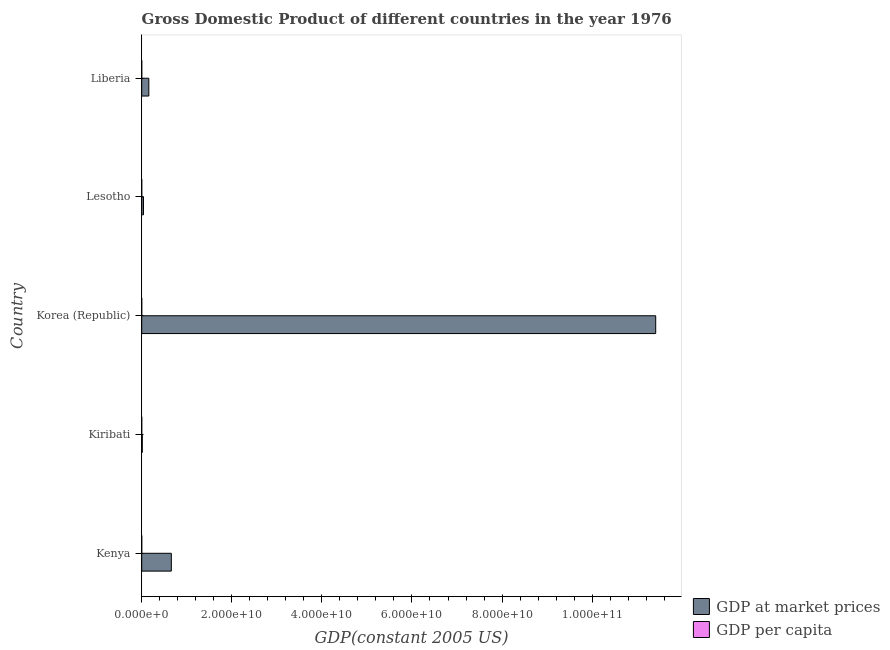Are the number of bars on each tick of the Y-axis equal?
Provide a succinct answer. Yes. How many bars are there on the 2nd tick from the top?
Give a very brief answer. 2. How many bars are there on the 2nd tick from the bottom?
Provide a succinct answer. 2. What is the label of the 4th group of bars from the top?
Your answer should be very brief. Kiribati. What is the gdp per capita in Lesotho?
Ensure brevity in your answer.  330.88. Across all countries, what is the maximum gdp at market prices?
Keep it short and to the point. 1.14e+11. Across all countries, what is the minimum gdp at market prices?
Keep it short and to the point. 1.24e+08. In which country was the gdp at market prices maximum?
Ensure brevity in your answer.  Korea (Republic). In which country was the gdp at market prices minimum?
Your answer should be very brief. Kiribati. What is the total gdp per capita in the graph?
Offer a very short reply. 7140.95. What is the difference between the gdp at market prices in Kenya and that in Lesotho?
Provide a short and direct response. 6.18e+09. What is the difference between the gdp per capita in Korea (Republic) and the gdp at market prices in Kiribati?
Provide a succinct answer. -1.24e+08. What is the average gdp at market prices per country?
Provide a succinct answer. 2.46e+1. What is the difference between the gdp at market prices and gdp per capita in Liberia?
Provide a short and direct response. 1.58e+09. In how many countries, is the gdp at market prices greater than 48000000000 US$?
Your answer should be very brief. 1. What is the ratio of the gdp at market prices in Kiribati to that in Lesotho?
Offer a terse response. 0.32. Is the difference between the gdp per capita in Kenya and Lesotho greater than the difference between the gdp at market prices in Kenya and Lesotho?
Provide a succinct answer. No. What is the difference between the highest and the second highest gdp at market prices?
Your response must be concise. 1.08e+11. What is the difference between the highest and the lowest gdp at market prices?
Your response must be concise. 1.14e+11. In how many countries, is the gdp at market prices greater than the average gdp at market prices taken over all countries?
Your response must be concise. 1. What does the 1st bar from the top in Korea (Republic) represents?
Your response must be concise. GDP per capita. What does the 2nd bar from the bottom in Lesotho represents?
Your answer should be very brief. GDP per capita. How many bars are there?
Give a very brief answer. 10. Are all the bars in the graph horizontal?
Provide a short and direct response. Yes. How many countries are there in the graph?
Your answer should be very brief. 5. Are the values on the major ticks of X-axis written in scientific E-notation?
Offer a very short reply. Yes. Does the graph contain any zero values?
Your answer should be compact. No. How many legend labels are there?
Give a very brief answer. 2. What is the title of the graph?
Your answer should be compact. Gross Domestic Product of different countries in the year 1976. What is the label or title of the X-axis?
Offer a terse response. GDP(constant 2005 US). What is the GDP(constant 2005 US) in GDP at market prices in Kenya?
Offer a very short reply. 6.57e+09. What is the GDP(constant 2005 US) in GDP per capita in Kenya?
Offer a terse response. 469.63. What is the GDP(constant 2005 US) in GDP at market prices in Kiribati?
Make the answer very short. 1.24e+08. What is the GDP(constant 2005 US) in GDP per capita in Kiribati?
Make the answer very short. 2216.2. What is the GDP(constant 2005 US) in GDP at market prices in Korea (Republic)?
Your response must be concise. 1.14e+11. What is the GDP(constant 2005 US) in GDP per capita in Korea (Republic)?
Your answer should be very brief. 3183.27. What is the GDP(constant 2005 US) of GDP at market prices in Lesotho?
Provide a succinct answer. 3.90e+08. What is the GDP(constant 2005 US) in GDP per capita in Lesotho?
Make the answer very short. 330.88. What is the GDP(constant 2005 US) in GDP at market prices in Liberia?
Offer a very short reply. 1.58e+09. What is the GDP(constant 2005 US) in GDP per capita in Liberia?
Give a very brief answer. 940.97. Across all countries, what is the maximum GDP(constant 2005 US) in GDP at market prices?
Give a very brief answer. 1.14e+11. Across all countries, what is the maximum GDP(constant 2005 US) of GDP per capita?
Your response must be concise. 3183.27. Across all countries, what is the minimum GDP(constant 2005 US) in GDP at market prices?
Provide a short and direct response. 1.24e+08. Across all countries, what is the minimum GDP(constant 2005 US) of GDP per capita?
Keep it short and to the point. 330.88. What is the total GDP(constant 2005 US) in GDP at market prices in the graph?
Your response must be concise. 1.23e+11. What is the total GDP(constant 2005 US) of GDP per capita in the graph?
Your answer should be compact. 7140.95. What is the difference between the GDP(constant 2005 US) of GDP at market prices in Kenya and that in Kiribati?
Your response must be concise. 6.45e+09. What is the difference between the GDP(constant 2005 US) of GDP per capita in Kenya and that in Kiribati?
Make the answer very short. -1746.57. What is the difference between the GDP(constant 2005 US) in GDP at market prices in Kenya and that in Korea (Republic)?
Offer a terse response. -1.08e+11. What is the difference between the GDP(constant 2005 US) of GDP per capita in Kenya and that in Korea (Republic)?
Your response must be concise. -2713.64. What is the difference between the GDP(constant 2005 US) of GDP at market prices in Kenya and that in Lesotho?
Give a very brief answer. 6.18e+09. What is the difference between the GDP(constant 2005 US) in GDP per capita in Kenya and that in Lesotho?
Your answer should be compact. 138.75. What is the difference between the GDP(constant 2005 US) of GDP at market prices in Kenya and that in Liberia?
Ensure brevity in your answer.  5.00e+09. What is the difference between the GDP(constant 2005 US) of GDP per capita in Kenya and that in Liberia?
Make the answer very short. -471.34. What is the difference between the GDP(constant 2005 US) of GDP at market prices in Kiribati and that in Korea (Republic)?
Give a very brief answer. -1.14e+11. What is the difference between the GDP(constant 2005 US) in GDP per capita in Kiribati and that in Korea (Republic)?
Ensure brevity in your answer.  -967.07. What is the difference between the GDP(constant 2005 US) of GDP at market prices in Kiribati and that in Lesotho?
Make the answer very short. -2.66e+08. What is the difference between the GDP(constant 2005 US) of GDP per capita in Kiribati and that in Lesotho?
Keep it short and to the point. 1885.33. What is the difference between the GDP(constant 2005 US) in GDP at market prices in Kiribati and that in Liberia?
Keep it short and to the point. -1.45e+09. What is the difference between the GDP(constant 2005 US) in GDP per capita in Kiribati and that in Liberia?
Your answer should be very brief. 1275.23. What is the difference between the GDP(constant 2005 US) of GDP at market prices in Korea (Republic) and that in Lesotho?
Your answer should be very brief. 1.14e+11. What is the difference between the GDP(constant 2005 US) of GDP per capita in Korea (Republic) and that in Lesotho?
Give a very brief answer. 2852.39. What is the difference between the GDP(constant 2005 US) in GDP at market prices in Korea (Republic) and that in Liberia?
Your answer should be compact. 1.13e+11. What is the difference between the GDP(constant 2005 US) of GDP per capita in Korea (Republic) and that in Liberia?
Your response must be concise. 2242.3. What is the difference between the GDP(constant 2005 US) in GDP at market prices in Lesotho and that in Liberia?
Your answer should be very brief. -1.19e+09. What is the difference between the GDP(constant 2005 US) in GDP per capita in Lesotho and that in Liberia?
Your response must be concise. -610.09. What is the difference between the GDP(constant 2005 US) in GDP at market prices in Kenya and the GDP(constant 2005 US) in GDP per capita in Kiribati?
Offer a very short reply. 6.57e+09. What is the difference between the GDP(constant 2005 US) of GDP at market prices in Kenya and the GDP(constant 2005 US) of GDP per capita in Korea (Republic)?
Provide a short and direct response. 6.57e+09. What is the difference between the GDP(constant 2005 US) in GDP at market prices in Kenya and the GDP(constant 2005 US) in GDP per capita in Lesotho?
Give a very brief answer. 6.57e+09. What is the difference between the GDP(constant 2005 US) of GDP at market prices in Kenya and the GDP(constant 2005 US) of GDP per capita in Liberia?
Give a very brief answer. 6.57e+09. What is the difference between the GDP(constant 2005 US) in GDP at market prices in Kiribati and the GDP(constant 2005 US) in GDP per capita in Korea (Republic)?
Offer a terse response. 1.24e+08. What is the difference between the GDP(constant 2005 US) in GDP at market prices in Kiribati and the GDP(constant 2005 US) in GDP per capita in Lesotho?
Make the answer very short. 1.24e+08. What is the difference between the GDP(constant 2005 US) in GDP at market prices in Kiribati and the GDP(constant 2005 US) in GDP per capita in Liberia?
Offer a terse response. 1.24e+08. What is the difference between the GDP(constant 2005 US) in GDP at market prices in Korea (Republic) and the GDP(constant 2005 US) in GDP per capita in Lesotho?
Your answer should be very brief. 1.14e+11. What is the difference between the GDP(constant 2005 US) of GDP at market prices in Korea (Republic) and the GDP(constant 2005 US) of GDP per capita in Liberia?
Offer a terse response. 1.14e+11. What is the difference between the GDP(constant 2005 US) in GDP at market prices in Lesotho and the GDP(constant 2005 US) in GDP per capita in Liberia?
Provide a short and direct response. 3.90e+08. What is the average GDP(constant 2005 US) in GDP at market prices per country?
Your response must be concise. 2.46e+1. What is the average GDP(constant 2005 US) of GDP per capita per country?
Provide a short and direct response. 1428.19. What is the difference between the GDP(constant 2005 US) of GDP at market prices and GDP(constant 2005 US) of GDP per capita in Kenya?
Your answer should be compact. 6.57e+09. What is the difference between the GDP(constant 2005 US) of GDP at market prices and GDP(constant 2005 US) of GDP per capita in Kiribati?
Ensure brevity in your answer.  1.24e+08. What is the difference between the GDP(constant 2005 US) in GDP at market prices and GDP(constant 2005 US) in GDP per capita in Korea (Republic)?
Ensure brevity in your answer.  1.14e+11. What is the difference between the GDP(constant 2005 US) of GDP at market prices and GDP(constant 2005 US) of GDP per capita in Lesotho?
Offer a very short reply. 3.90e+08. What is the difference between the GDP(constant 2005 US) in GDP at market prices and GDP(constant 2005 US) in GDP per capita in Liberia?
Provide a succinct answer. 1.58e+09. What is the ratio of the GDP(constant 2005 US) of GDP at market prices in Kenya to that in Kiribati?
Keep it short and to the point. 52.98. What is the ratio of the GDP(constant 2005 US) in GDP per capita in Kenya to that in Kiribati?
Your answer should be very brief. 0.21. What is the ratio of the GDP(constant 2005 US) of GDP at market prices in Kenya to that in Korea (Republic)?
Ensure brevity in your answer.  0.06. What is the ratio of the GDP(constant 2005 US) in GDP per capita in Kenya to that in Korea (Republic)?
Provide a succinct answer. 0.15. What is the ratio of the GDP(constant 2005 US) in GDP at market prices in Kenya to that in Lesotho?
Your answer should be compact. 16.86. What is the ratio of the GDP(constant 2005 US) of GDP per capita in Kenya to that in Lesotho?
Provide a short and direct response. 1.42. What is the ratio of the GDP(constant 2005 US) of GDP at market prices in Kenya to that in Liberia?
Your answer should be very brief. 4.17. What is the ratio of the GDP(constant 2005 US) in GDP per capita in Kenya to that in Liberia?
Provide a short and direct response. 0.5. What is the ratio of the GDP(constant 2005 US) in GDP at market prices in Kiribati to that in Korea (Republic)?
Keep it short and to the point. 0. What is the ratio of the GDP(constant 2005 US) in GDP per capita in Kiribati to that in Korea (Republic)?
Your response must be concise. 0.7. What is the ratio of the GDP(constant 2005 US) in GDP at market prices in Kiribati to that in Lesotho?
Provide a short and direct response. 0.32. What is the ratio of the GDP(constant 2005 US) of GDP per capita in Kiribati to that in Lesotho?
Your answer should be compact. 6.7. What is the ratio of the GDP(constant 2005 US) in GDP at market prices in Kiribati to that in Liberia?
Provide a succinct answer. 0.08. What is the ratio of the GDP(constant 2005 US) in GDP per capita in Kiribati to that in Liberia?
Offer a terse response. 2.36. What is the ratio of the GDP(constant 2005 US) of GDP at market prices in Korea (Republic) to that in Lesotho?
Offer a very short reply. 292.78. What is the ratio of the GDP(constant 2005 US) in GDP per capita in Korea (Republic) to that in Lesotho?
Your answer should be compact. 9.62. What is the ratio of the GDP(constant 2005 US) of GDP at market prices in Korea (Republic) to that in Liberia?
Your answer should be compact. 72.36. What is the ratio of the GDP(constant 2005 US) of GDP per capita in Korea (Republic) to that in Liberia?
Offer a terse response. 3.38. What is the ratio of the GDP(constant 2005 US) of GDP at market prices in Lesotho to that in Liberia?
Ensure brevity in your answer.  0.25. What is the ratio of the GDP(constant 2005 US) in GDP per capita in Lesotho to that in Liberia?
Keep it short and to the point. 0.35. What is the difference between the highest and the second highest GDP(constant 2005 US) of GDP at market prices?
Offer a very short reply. 1.08e+11. What is the difference between the highest and the second highest GDP(constant 2005 US) of GDP per capita?
Your answer should be compact. 967.07. What is the difference between the highest and the lowest GDP(constant 2005 US) in GDP at market prices?
Ensure brevity in your answer.  1.14e+11. What is the difference between the highest and the lowest GDP(constant 2005 US) of GDP per capita?
Keep it short and to the point. 2852.39. 